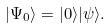Convert formula to latex. <formula><loc_0><loc_0><loc_500><loc_500>| \Psi _ { 0 } \rangle = | 0 \rangle | \psi \rangle .</formula> 